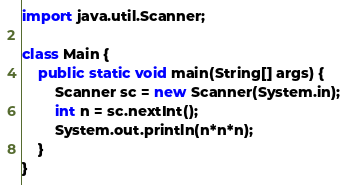Convert code to text. <code><loc_0><loc_0><loc_500><loc_500><_Java_>import java.util.Scanner;
 
class Main {
    public static void main(String[] args) {
        Scanner sc = new Scanner(System.in);
        int n = sc.nextInt();
        System.out.println(n*n*n);
    }
}
</code> 